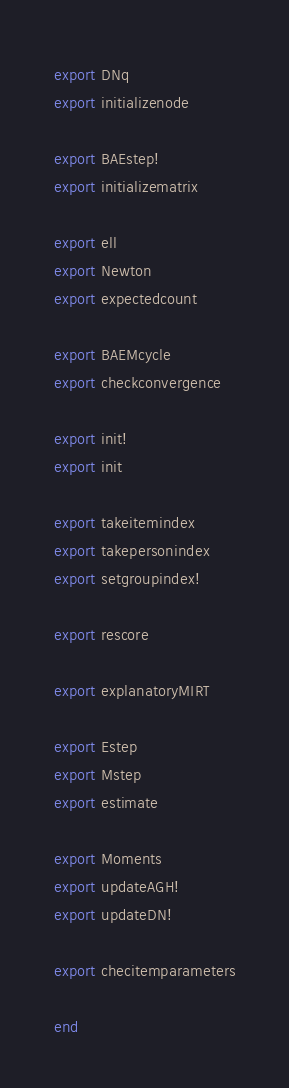Convert code to text. <code><loc_0><loc_0><loc_500><loc_500><_Julia_>export DNq
export initializenode

export BAEstep!
export initializematrix

export ell
export Newton
export expectedcount

export BAEMcycle
export checkconvergence

export init!
export init

export takeitemindex
export takepersonindex
export setgroupindex!

export rescore

export explanatoryMIRT

export Estep
export Mstep
export estimate

export Moments
export updateAGH!
export updateDN!

export checitemparameters

end
</code> 